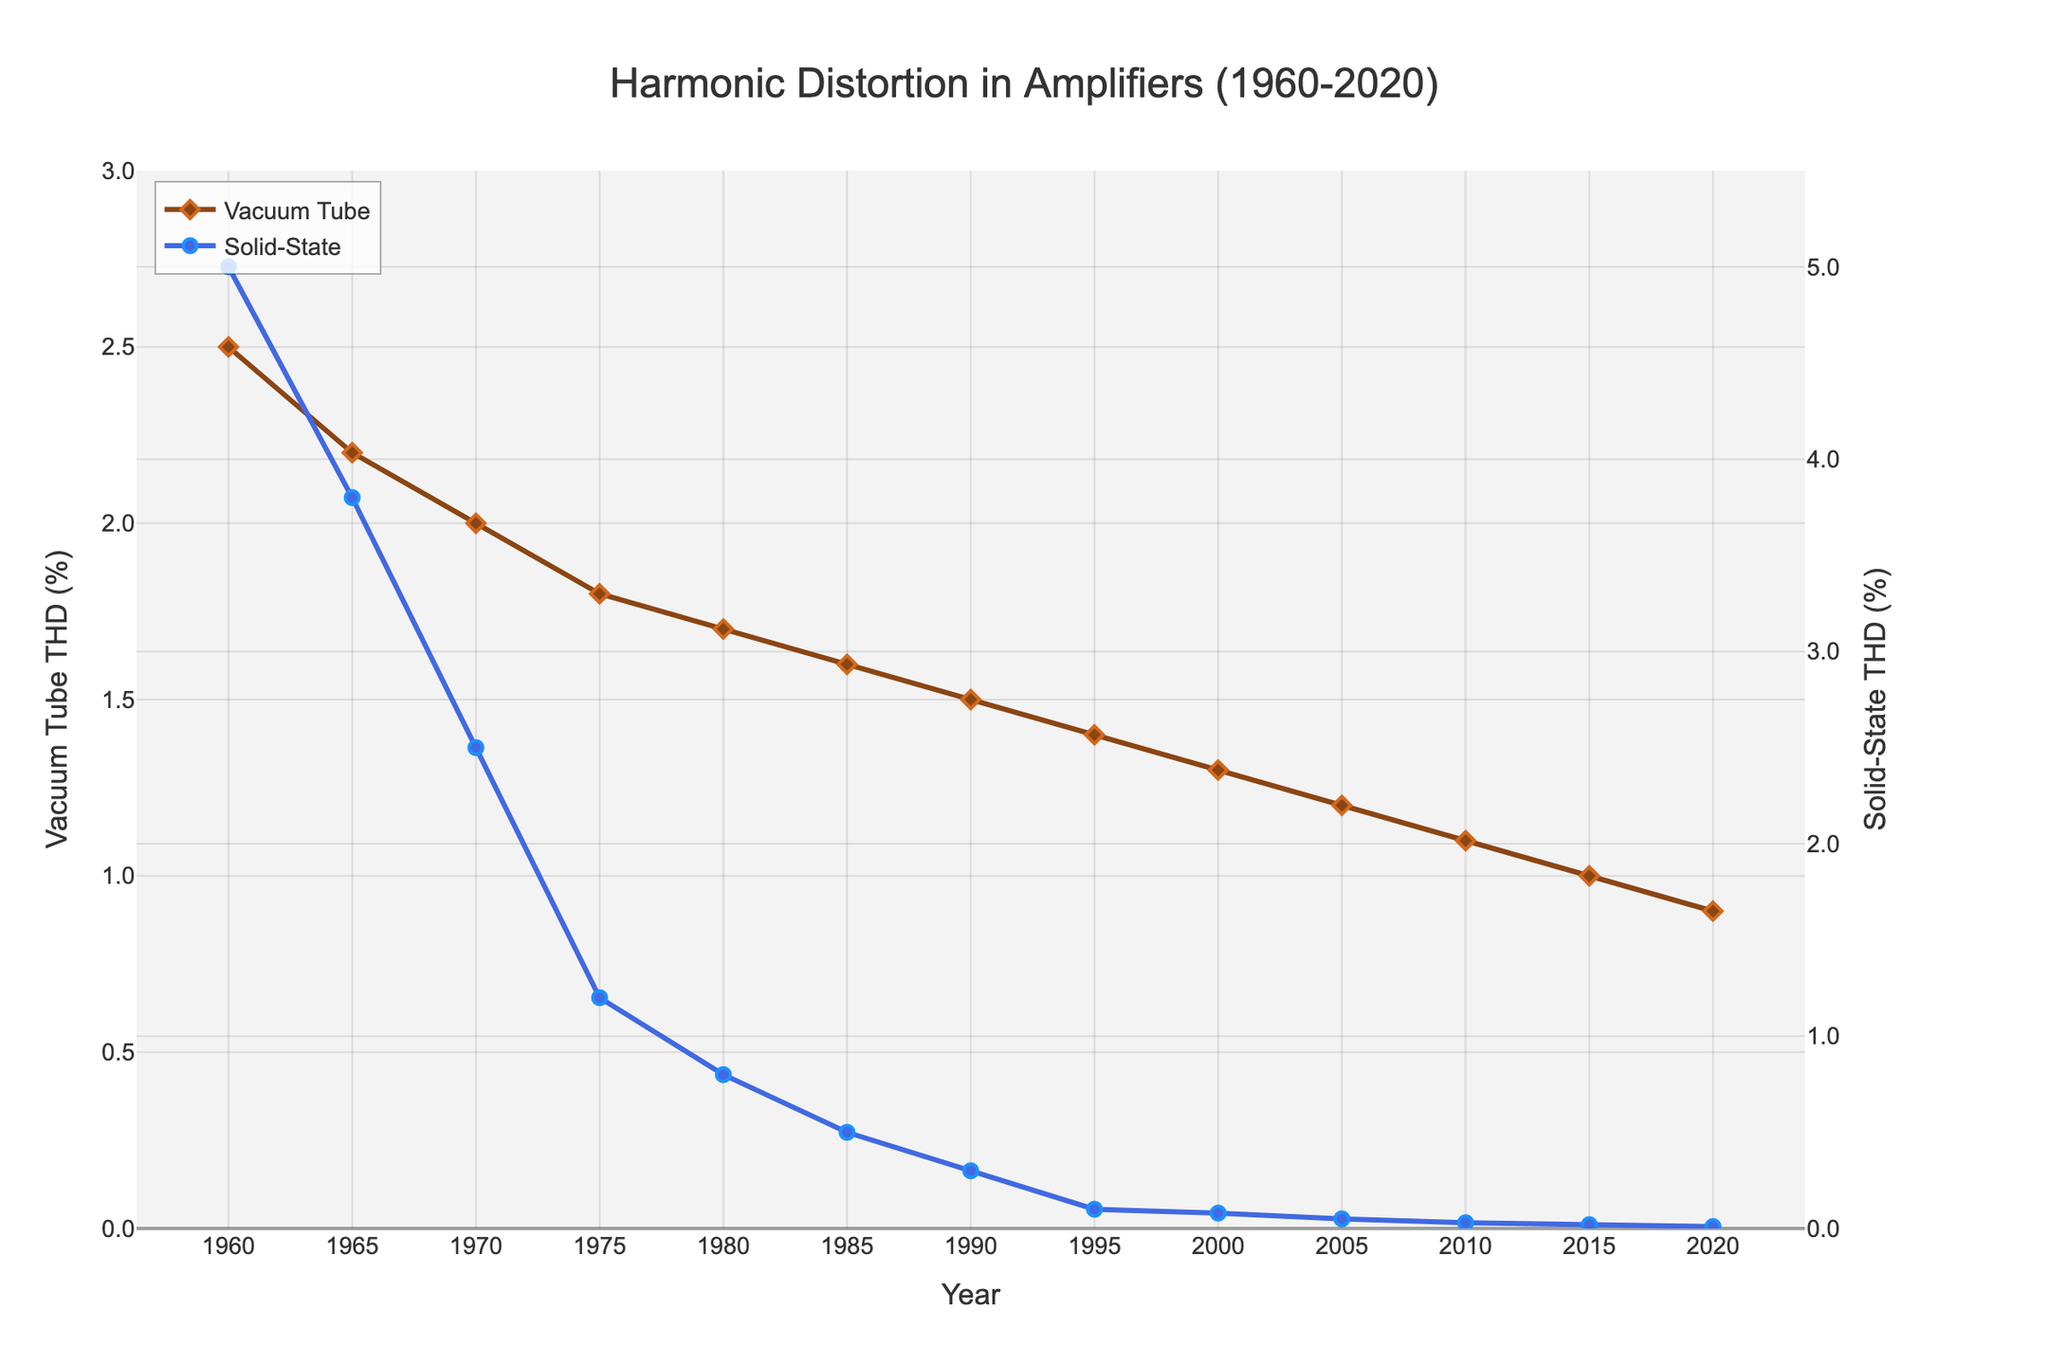What's the overall trend in harmonic distortion for vacuum tube amplifiers from 1960 to 2020? The percentage of Total Harmonic Distortion (% THD) in vacuum tube amplifiers steadily decreases from 2.5% in 1960 to 0.9% in 2020.
Answer: Decreasing trend What's the overall trend in harmonic distortion for solid-state amplifiers from 1960 to 2020? The percentage of Total Harmonic Distortion (% THD) in solid-state amplifiers rapidly decreases from 5.0% in 1960 to 0.01% in 2020.
Answer: Rapidly decreasing trend How does the harmonic distortion of vacuum tube amplifiers in 1965 compare to that of solid-state amplifiers in the same year? In 1965, vacuum tube amplifiers have a % THD of 2.2%, while solid-state amplifiers have a % THD of 3.8%.
Answer: Solid-state amplifiers have higher % THD Calculate the percentage decrease in harmonic distortion for vacuum tube amplifiers from 1960 to 2020. The decrease is from 2.5% to 0.9%, so the percentage decrease is (2.5 - 0.9) / 2.5 * 100 = 64%.
Answer: 64% Which type of amplifier shows a greater reduction in harmonic distortion from 1960 to 2020 and by how much? Vacuum tube amplifiers reduce from 2.5% to 0.9% (1.6% absolute decrease), while solid-state amplifiers reduce from 5.0% to 0.01% (4.99% absolute decrease); thus, solid-state amplifiers show a greater reduction.
Answer: Solid-state amplifiers by 3.39% What is the harmonic distortion in solid-state amplifiers in 2020 compared to vacuum tube amplifiers in 2020? In 2020, solid-state amplifiers have 0.01% THD, and vacuum tube amplifiers have 0.9% THD.
Answer: Solid-state amplifiers have lower % THD What year did both types of amplifiers have approximately the same percentage of harmonic distortion? Around 1975, vacuum tube amplifiers have 1.8% THD, and solid-state amplifiers have 1.2% THD, which are relatively close.
Answer: 1975 How many times higher is the harmonic distortion in vacuum tube amplifiers compared to solid-state amplifiers in 1985? In 1985, vacuum tube amplifiers have 1.6% THD, and solid-state amplifiers have 0.5% THD; thus, 1.6 / 0.5 = 3.2 times higher.
Answer: 3.2 times higher During which decade did vacuum tube amplifiers experience the most significant reduction in harmonic distortion? The most significant reduction in vacuum tube amplifiers occurs during the 1970s, from 2.0% in 1970 to 1.8% in 1975.
Answer: 1970s 